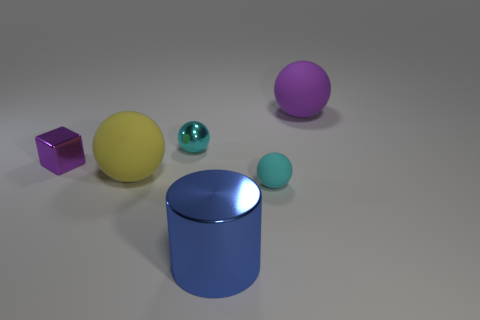There is a small cyan ball behind the small rubber ball; what is its material? Based on the image, the small cyan ball appears to have a shiny, reflective surface, akin to materials such as smooth plastic or polished metal. However, without additional context or physical testing, the exact material composition cannot be determined solely from the visual characteristics presented in the image. 